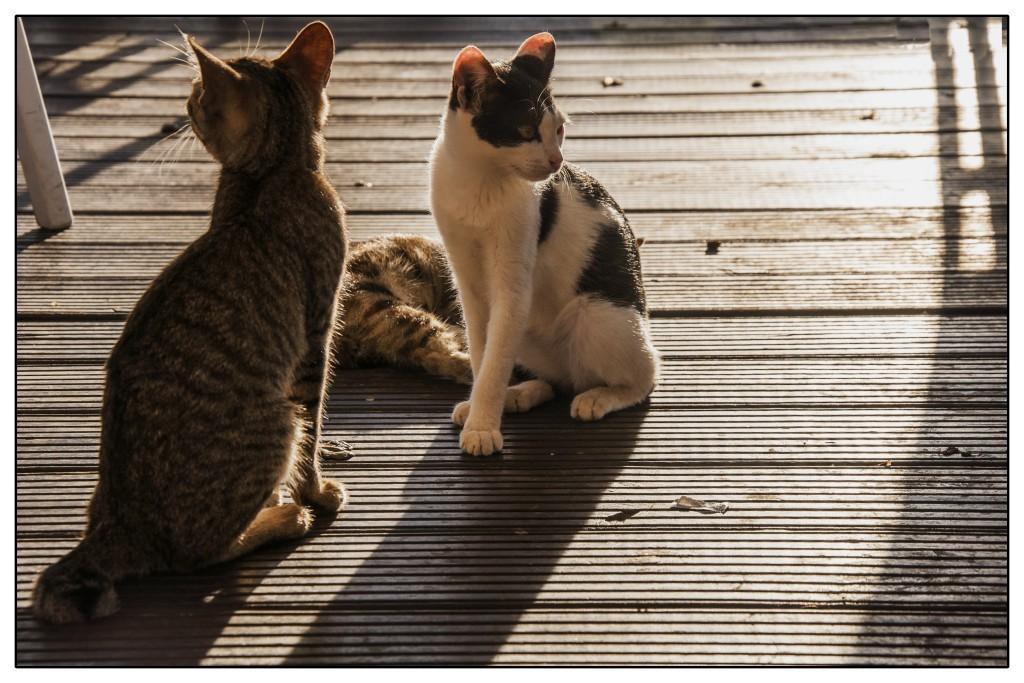Can you describe this image briefly? In this image there are three cats on the wooden surface, there is an object towards the left of the image, there are objects on the wooden surface. 